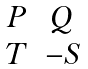<formula> <loc_0><loc_0><loc_500><loc_500>\begin{matrix} P & Q \\ T & - S \end{matrix}</formula> 